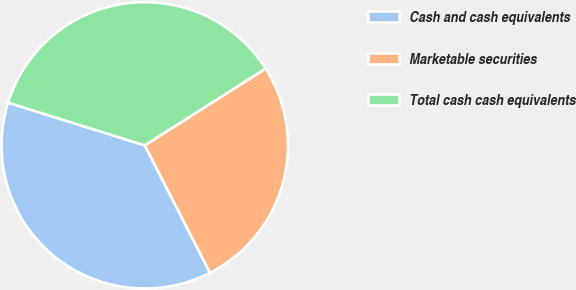Convert chart to OTSL. <chart><loc_0><loc_0><loc_500><loc_500><pie_chart><fcel>Cash and cash equivalents<fcel>Marketable securities<fcel>Total cash cash equivalents<nl><fcel>37.36%<fcel>26.47%<fcel>36.17%<nl></chart> 